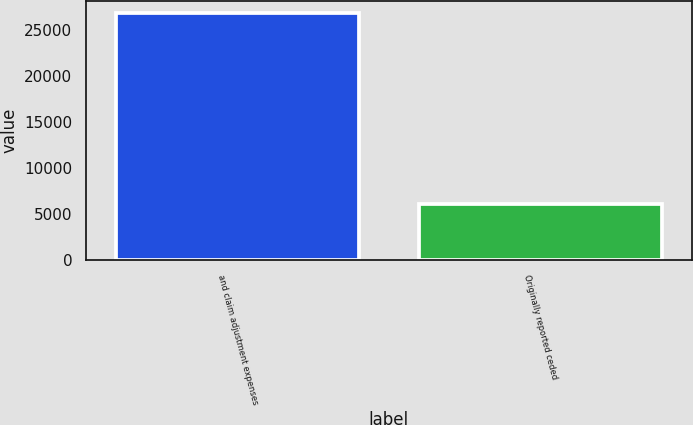<chart> <loc_0><loc_0><loc_500><loc_500><bar_chart><fcel>and claim adjustment expenses<fcel>Originally reported ceded<nl><fcel>26850<fcel>6091<nl></chart> 